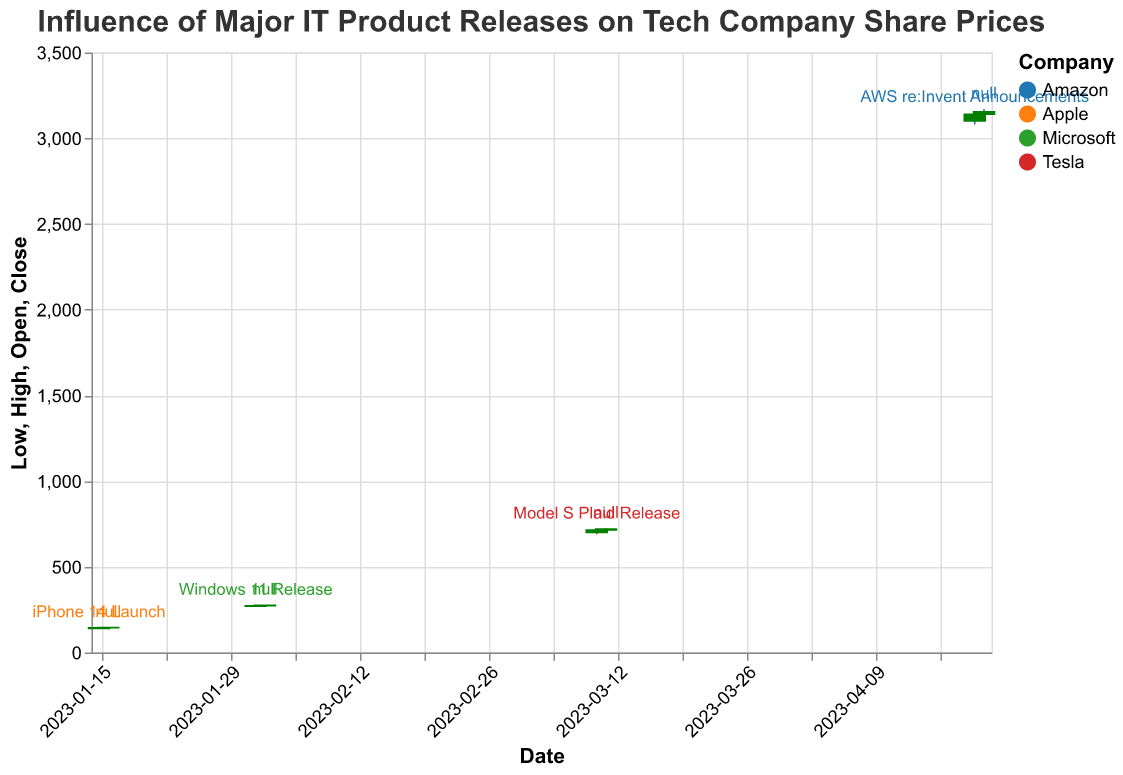What is the date of the iPhone 14 Launch? The iPhone 14 Launch date is indicated on the plot above the respective candlestick for Apple.
Answer: 2023-01-15 Which company has the highest closing stock price? By examining the highest point on the "Close" axis, Amazon has the highest closing price at 3155.00.
Answer: Amazon What is the closing price of Microsoft on the day of the Windows 11 Release? Locate the candlestick corresponding to Microsoft on February 1, 2023, and observe the "Close" value.
Answer: 273.00 How did Tesla's stock price move on the day following the Model S Plaid Release compared to the release day? Compare the closing price for Tesla on March 10, 2023 (715.00), with the closing price on March 11, 2023 (720.00).
Answer: It increased What is the range of Apple's stock price on January 15, 2023? The range can be found by subtracting the "Low" value (138.00) from the "High" value (145.00) for that day.
Answer: 7.00 Did Amazon's stock price increase or decrease after the AWS re:Invent Announcements? Compare the closing price for Amazon on April 20, 2023 (3140.00), with the closing price on April 21, 2023 (3155.00).
Answer: It increased Which product release had the highest volume of stock traded? Check the "Volume" data for each product release; the iPhone 14 Launch had the highest volume at 105,000,000.
Answer: iPhone 14 Launch What is the difference in closing price between the highest closing price and the lowest closing price in the entire dataset? Find the highest closing price (Amazon, 3155.00) and the lowest closing price (Apple, 144.00), then subtract the lowest from the highest.
Answer: 3011.00 How does the closing price on the day of the Windows 11 Release compare to the following day? Compare the closing price for Microsoft on February 1, 2023 (273.00), with the closing price on February 2, 2023 (275.00).
Answer: It increased Which day had a higher trading volume, the iPhone 14 Launch or the Model S Plaid Release? Compare the volumes for Apple on January 15, 2023 (105,000,000) and Tesla on March 10, 2023 (75,000,000).
Answer: iPhone 14 Launch 